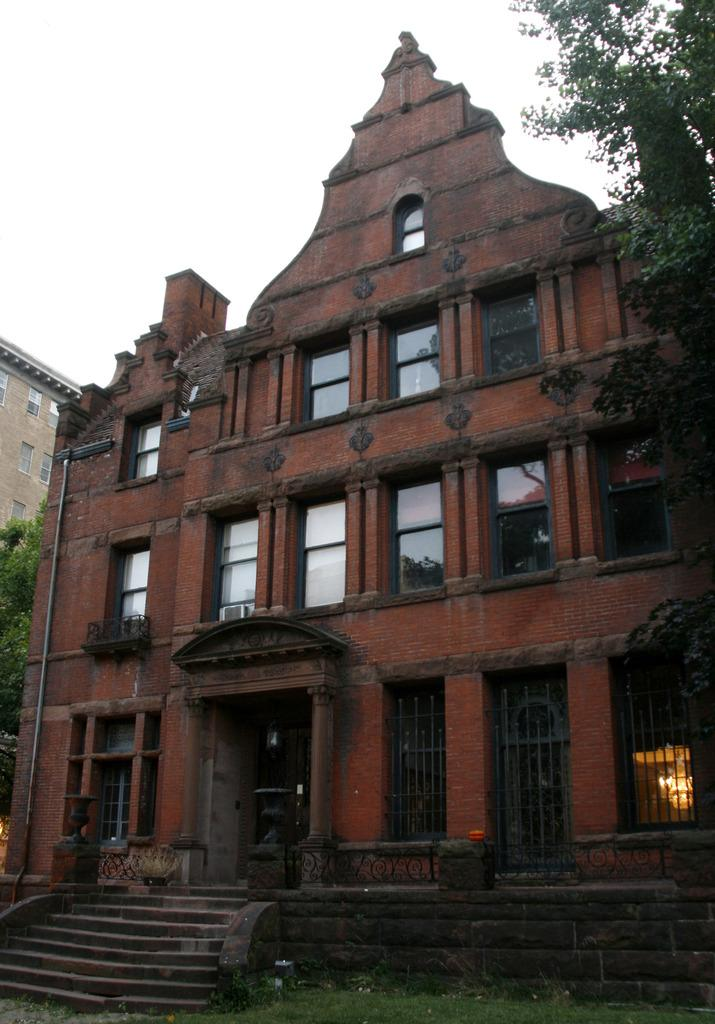What type of vegetation is visible in the image? There is grass in the image. What architectural feature can be seen in the image? There are stairs in the image. What type of structures are present in the image? There are buildings in the image. What other natural elements can be seen in the image? There are trees in the image. Can you tell me how many stockings are hanging from the trees in the image? There are no stockings hanging from the trees in the image. What type of competition is taking place in the image? There is no competition present in the image. 